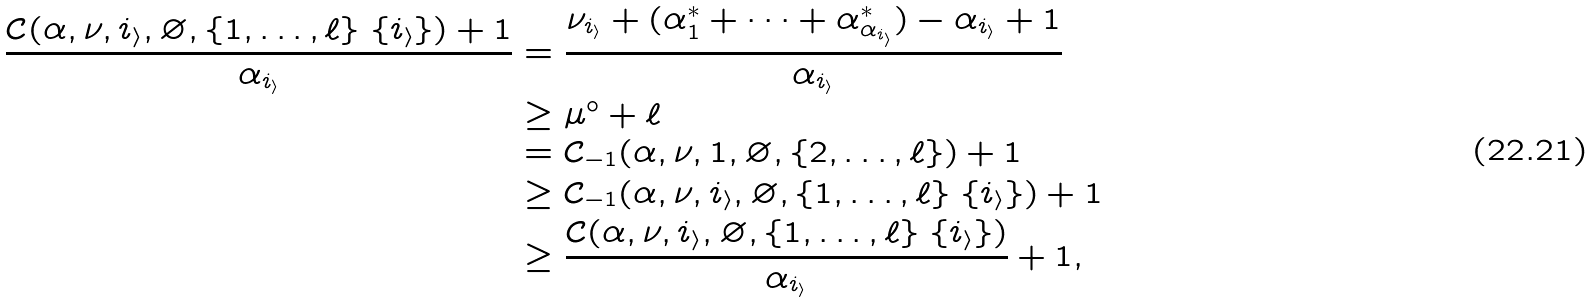<formula> <loc_0><loc_0><loc_500><loc_500>\frac { \mathcal { C } ( \alpha , \nu , i _ { \mathcal { i } } , \varnothing , \{ 1 , \dots , \ell \} \ \{ i _ { \mathcal { i } } \} ) + 1 } { \alpha _ { i _ { \mathcal { i } } } } & = \frac { \nu _ { i _ { \mathcal { i } } } + ( \alpha ^ { * } _ { 1 } + \cdots + \alpha ^ { * } _ { \alpha _ { i _ { \mathcal { i } } } } ) - \alpha _ { i _ { \mathcal { i } } } + 1 } { \alpha _ { i _ { \mathcal { i } } } } \\ & \geq \mu ^ { \circ } + \ell \\ & = \mathcal { C } _ { - 1 } ( \alpha , \nu , 1 , \varnothing , \{ 2 , \dots , \ell \} ) + 1 \\ & \geq \mathcal { C } _ { - 1 } ( \alpha , \nu , i _ { \mathcal { i } } , \varnothing , \{ 1 , \dots , \ell \} \ \{ i _ { \mathcal { i } } \} ) + 1 \\ & \geq \frac { \mathcal { C } ( \alpha , \nu , i _ { \mathcal { i } } , \varnothing , \{ 1 , \dots , \ell \} \ \{ i _ { \mathcal { i } } \} ) } { \alpha _ { i _ { \mathcal { i } } } } + 1 ,</formula> 